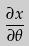<formula> <loc_0><loc_0><loc_500><loc_500>\frac { \partial x } { \partial \theta }</formula> 